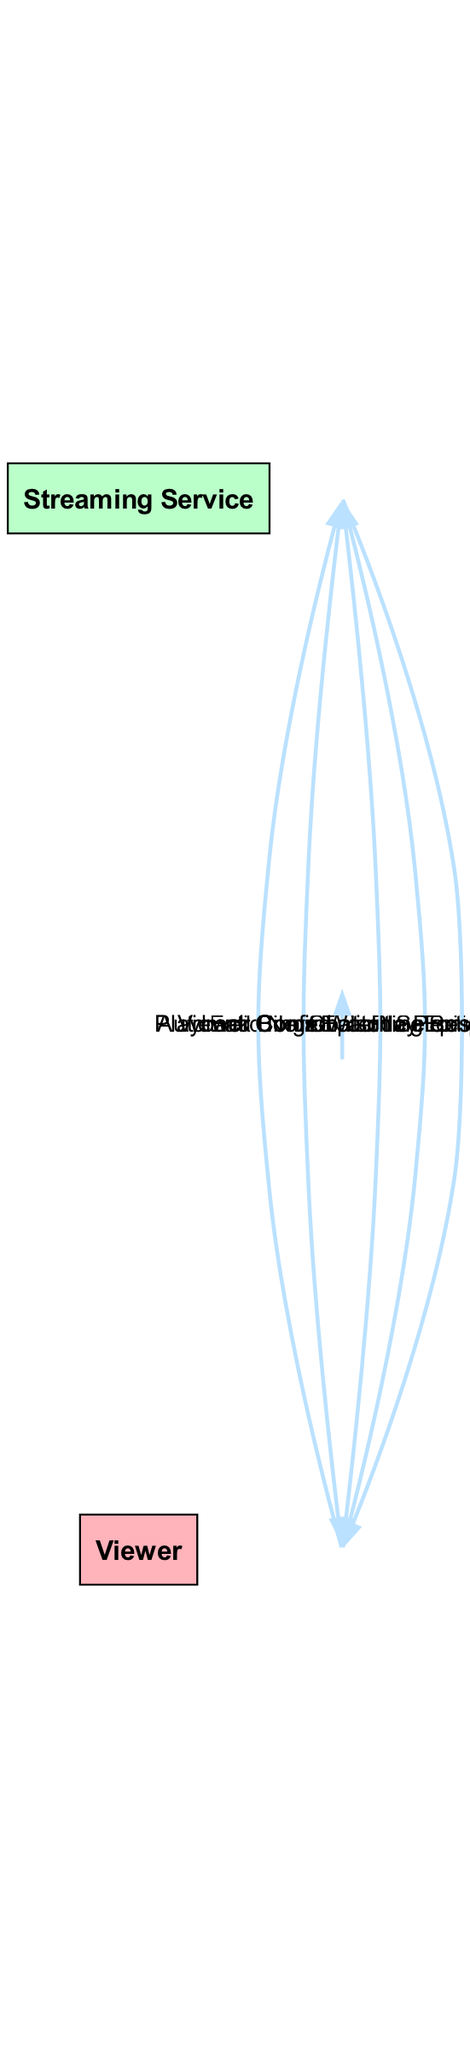What are the two main actors in the diagram? The diagram includes "Viewer" and "Streaming Service" as the primary actors involved in the interaction during the binge-watching session.
Answer: Viewer, Streaming Service How many actions are present in the diagram? There are a total of eight action elements depicted in the diagram, which represent various interactions between the viewer and the streaming service.
Answer: Eight What action follows "Play Episode" in the sequence? The action that follows "Play Episode" in the sequence is "Automatic Next Episode Prompt," indicating the service's response to the viewer starting an episode.
Answer: Automatic Next Episode Prompt Which action involves the viewer deciding whether to continue watching? The action that involves the viewer making a decision about continuing or exiting the binge-watching session is "Viewer Confirmation." This step is crucial as it determines the viewer's ongoing engagement.
Answer: Viewer Confirmation What is the direction of the interaction from "Automatic Next Episode Prompt" to "Viewer Confirmation"? The interaction flows from "Automatic Next Episode Prompt" to "Viewer Confirmation," indicating that the service prompts the viewer, who then needs to confirm whether they want to proceed.
Answer: Forward How does the "Viewer" control playback during the session? The viewer controls playback using the action labeled "Playback Control," which allows them to pause, rewind, or fast-forward through the content as they prefer during the binge-watching experience.
Answer: Playback Control What is the last action taken by the viewer in the diagram? The final action taken by the viewer to conclude their viewing experience is "End Binge-Watching Session," marking the end of the interaction with the streaming service.
Answer: End Binge-Watching Session What type of system is represented in the diagram? The system represented in the diagram is a "Streaming Service," which provides access to shows and movies for the viewer to enjoy.
Answer: Streaming Service 